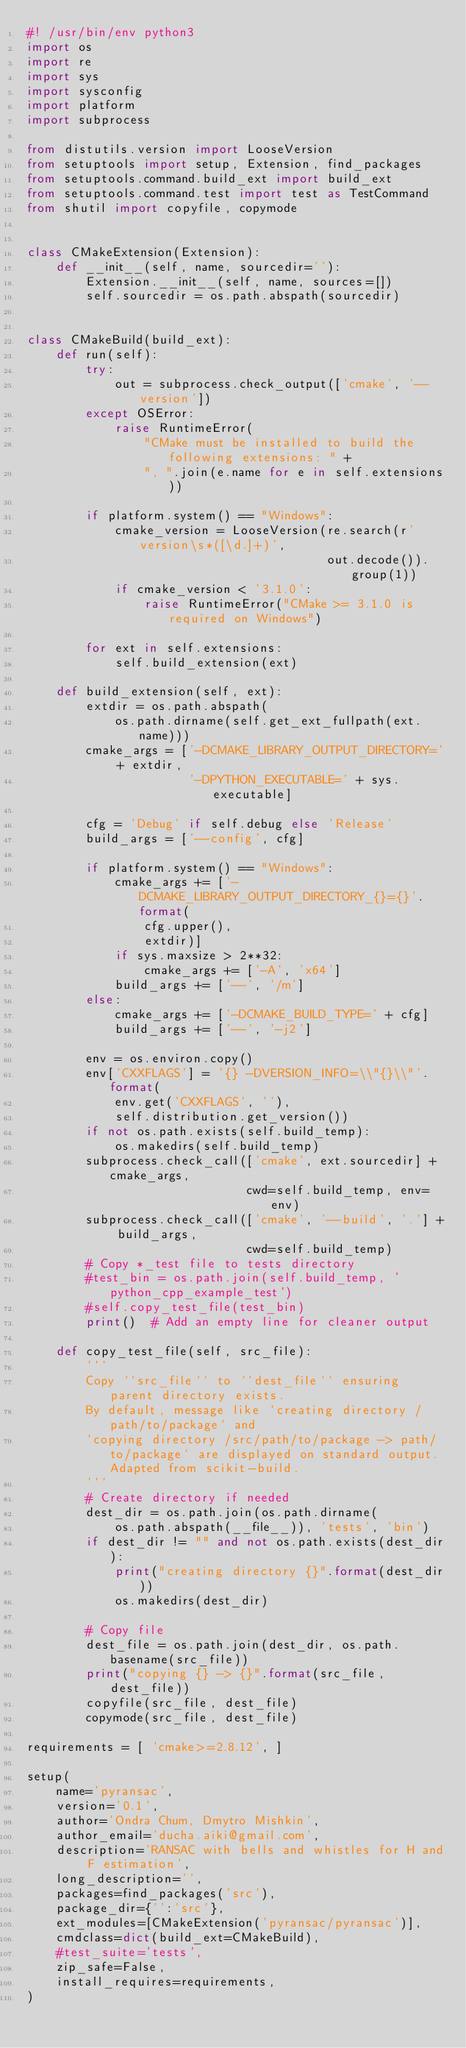Convert code to text. <code><loc_0><loc_0><loc_500><loc_500><_Python_>#! /usr/bin/env python3
import os
import re
import sys
import sysconfig
import platform
import subprocess

from distutils.version import LooseVersion
from setuptools import setup, Extension, find_packages
from setuptools.command.build_ext import build_ext
from setuptools.command.test import test as TestCommand
from shutil import copyfile, copymode


class CMakeExtension(Extension):
    def __init__(self, name, sourcedir=''):
        Extension.__init__(self, name, sources=[])
        self.sourcedir = os.path.abspath(sourcedir)


class CMakeBuild(build_ext):
    def run(self):
        try:
            out = subprocess.check_output(['cmake', '--version'])
        except OSError:
            raise RuntimeError(
                "CMake must be installed to build the following extensions: " +
                ", ".join(e.name for e in self.extensions))

        if platform.system() == "Windows":
            cmake_version = LooseVersion(re.search(r'version\s*([\d.]+)',
                                         out.decode()).group(1))
            if cmake_version < '3.1.0':
                raise RuntimeError("CMake >= 3.1.0 is required on Windows")

        for ext in self.extensions:
            self.build_extension(ext)

    def build_extension(self, ext):
        extdir = os.path.abspath(
            os.path.dirname(self.get_ext_fullpath(ext.name)))
        cmake_args = ['-DCMAKE_LIBRARY_OUTPUT_DIRECTORY=' + extdir,
                      '-DPYTHON_EXECUTABLE=' + sys.executable]

        cfg = 'Debug' if self.debug else 'Release'
        build_args = ['--config', cfg]

        if platform.system() == "Windows":
            cmake_args += ['-DCMAKE_LIBRARY_OUTPUT_DIRECTORY_{}={}'.format(
                cfg.upper(),
                extdir)]
            if sys.maxsize > 2**32:
                cmake_args += ['-A', 'x64']
            build_args += ['--', '/m']
        else:
            cmake_args += ['-DCMAKE_BUILD_TYPE=' + cfg]
            build_args += ['--', '-j2']

        env = os.environ.copy()
        env['CXXFLAGS'] = '{} -DVERSION_INFO=\\"{}\\"'.format(
            env.get('CXXFLAGS', ''),
            self.distribution.get_version())
        if not os.path.exists(self.build_temp):
            os.makedirs(self.build_temp)
        subprocess.check_call(['cmake', ext.sourcedir] + cmake_args,
                              cwd=self.build_temp, env=env)
        subprocess.check_call(['cmake', '--build', '.'] + build_args,
                              cwd=self.build_temp)
        # Copy *_test file to tests directory
        #test_bin = os.path.join(self.build_temp, 'python_cpp_example_test')
        #self.copy_test_file(test_bin)
        print()  # Add an empty line for cleaner output

    def copy_test_file(self, src_file):
        '''
        Copy ``src_file`` to ``dest_file`` ensuring parent directory exists.
        By default, message like `creating directory /path/to/package` and
        `copying directory /src/path/to/package -> path/to/package` are displayed on standard output. Adapted from scikit-build.
        '''
        # Create directory if needed
        dest_dir = os.path.join(os.path.dirname(
            os.path.abspath(__file__)), 'tests', 'bin')
        if dest_dir != "" and not os.path.exists(dest_dir):
            print("creating directory {}".format(dest_dir))
            os.makedirs(dest_dir)

        # Copy file
        dest_file = os.path.join(dest_dir, os.path.basename(src_file))
        print("copying {} -> {}".format(src_file, dest_file))
        copyfile(src_file, dest_file)
        copymode(src_file, dest_file)

requirements = [ 'cmake>=2.8.12', ]

setup(
    name='pyransac',
    version='0.1',
    author='Ondra Chum, Dmytro Mishkin',
    author_email='ducha.aiki@gmail.com',
    description='RANSAC with bells and whistles for H and F estimation',
    long_description='',
    packages=find_packages('src'),
    package_dir={'':'src'},
    ext_modules=[CMakeExtension('pyransac/pyransac')],
    cmdclass=dict(build_ext=CMakeBuild),
    #test_suite='tests',
    zip_safe=False,
    install_requires=requirements,
)
</code> 